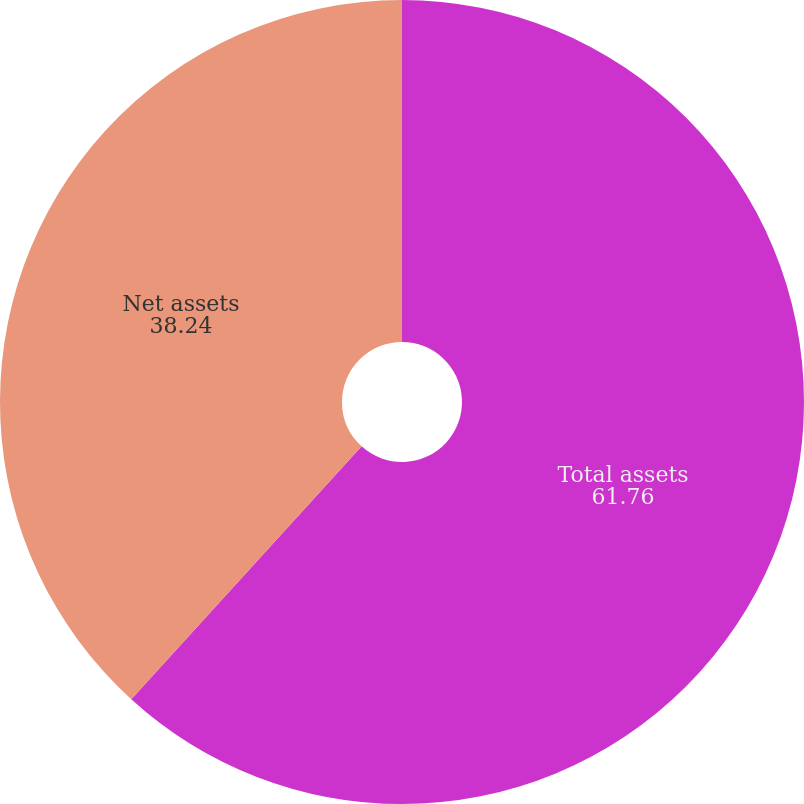Convert chart. <chart><loc_0><loc_0><loc_500><loc_500><pie_chart><fcel>Total assets<fcel>Net assets<nl><fcel>61.76%<fcel>38.24%<nl></chart> 